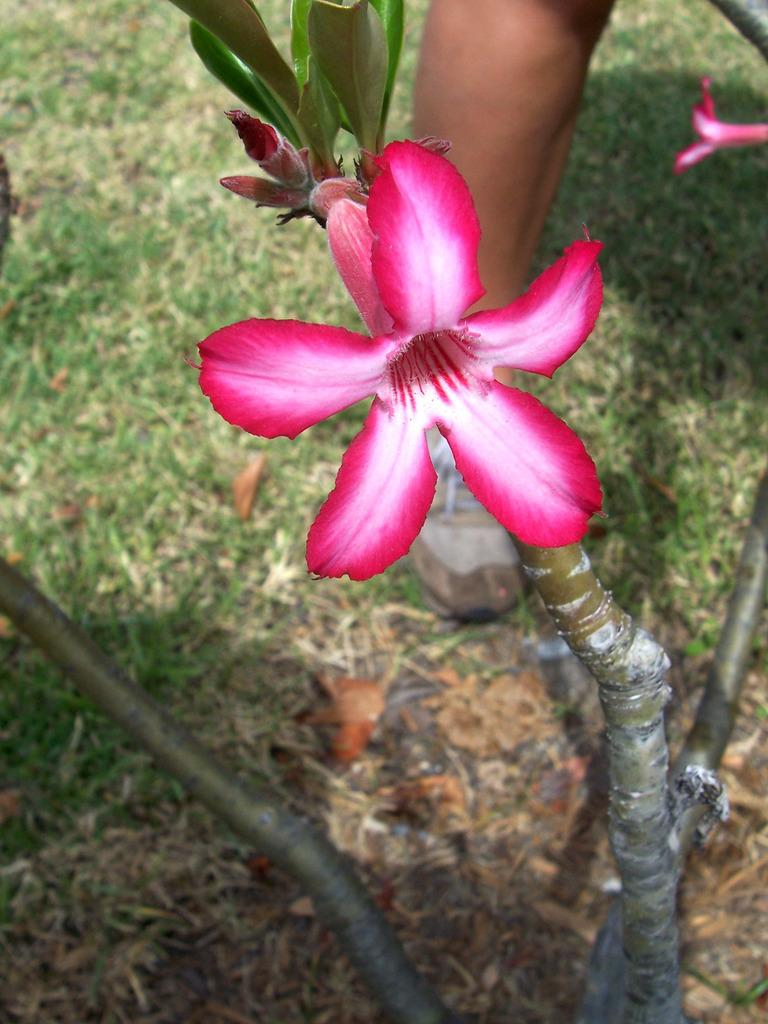Who or what is present in the image? There is a person in the image. What is the person wearing on their foot? The person is wearing a shoe. What is the person standing near? The person is standing near a plant. What type of plant is it? The plant has flowers. What can be seen on the left side of the image? There is grass and leaves on the left side of the image. What type of cord is being used by the person in the image? There is no cord visible in the image. 